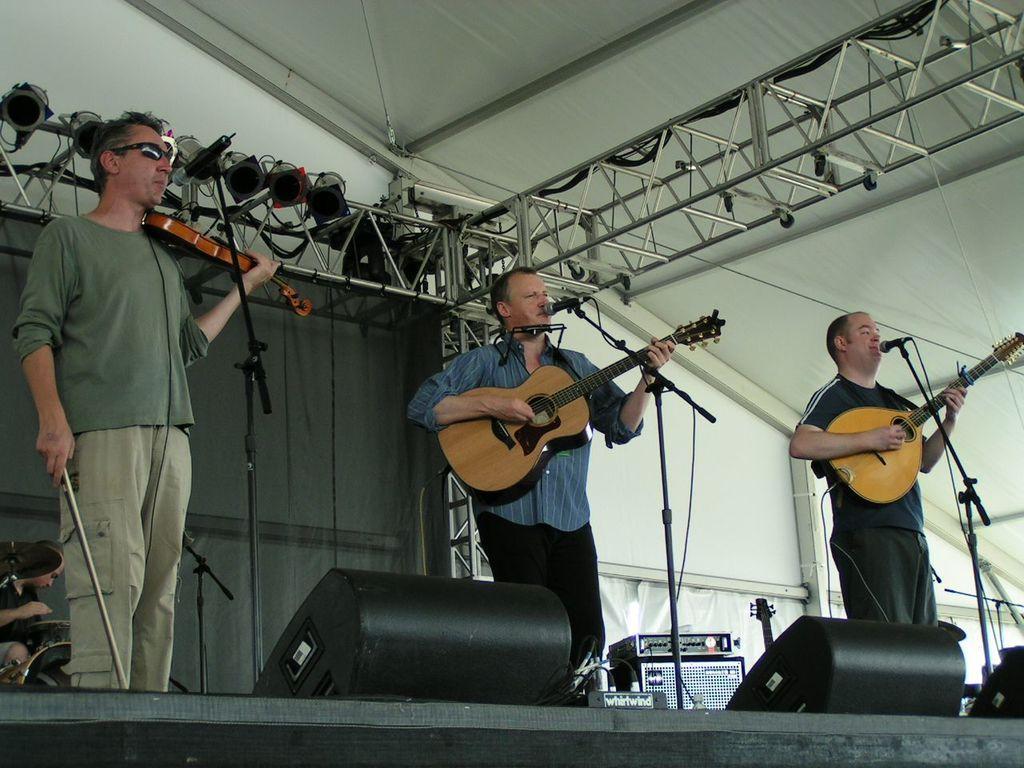Can you describe this image briefly? In this picture there are three people those who are standing on the stage by holding the guitar in there hands and there are mic in front of them, there are speakers at the left and right side of the image and there are spotlights around the area of the image. 